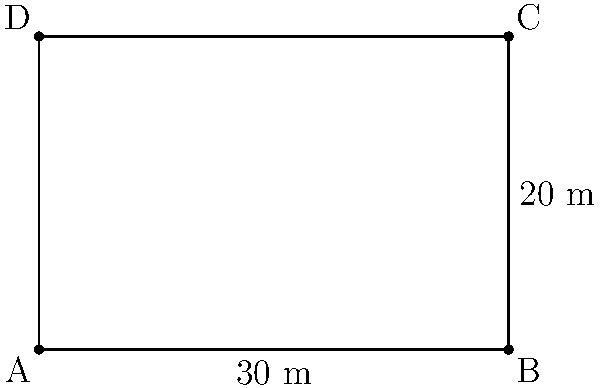As a former local council member, you're tasked with determining the perimeter of a rectangular plot of land for a new community garden in Rathfriland. The plot measures 30 meters in length and 20 meters in width. What is the total perimeter of this rectangular plot? To find the perimeter of a rectangular plot, we need to follow these steps:

1. Identify the length and width of the rectangle:
   Length (l) = 30 meters
   Width (w) = 20 meters

2. Recall the formula for the perimeter of a rectangle:
   Perimeter = 2(length + width) or P = 2(l + w)

3. Substitute the values into the formula:
   P = 2(30 m + 20 m)

4. Calculate the sum inside the parentheses:
   P = 2(50 m)

5. Multiply:
   P = 100 meters

Therefore, the perimeter of the rectangular plot is 100 meters.
Answer: 100 meters 